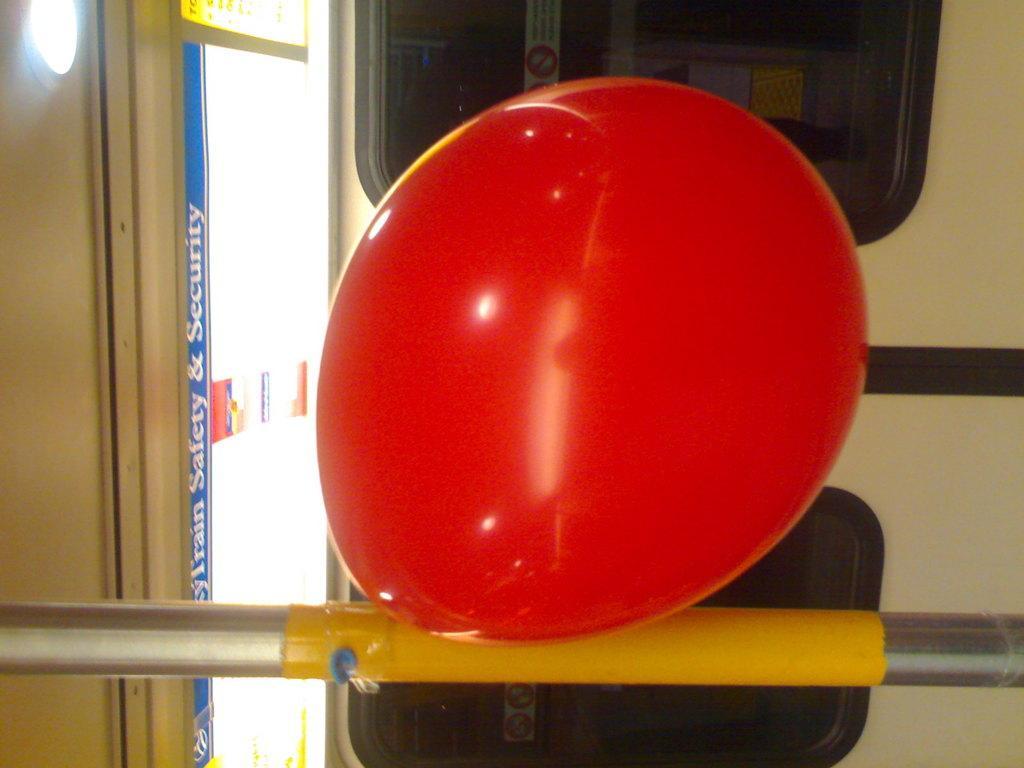Describe this image in one or two sentences. In front of the image there is a balloon on the metal rod, behind the balloon there are glass windows, beside the balloon there is a poster beside the door. 